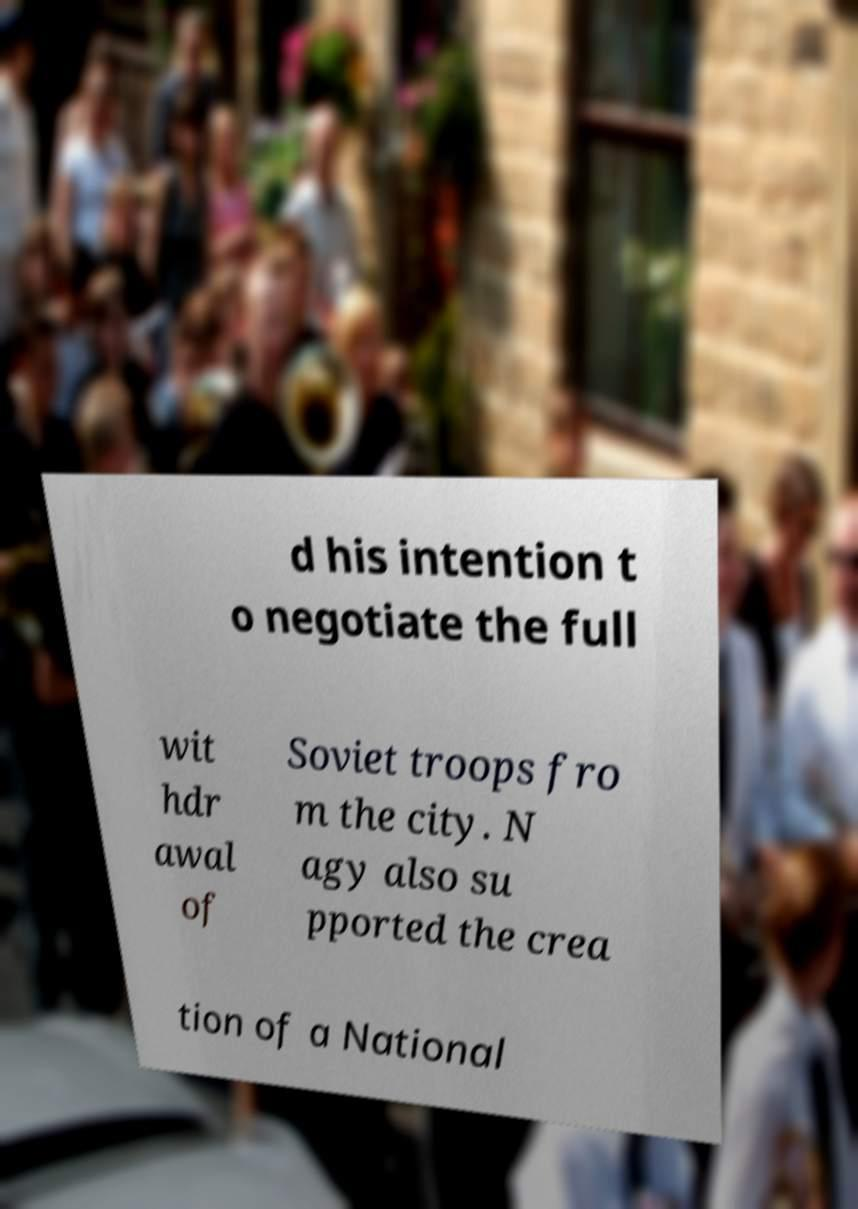Could you assist in decoding the text presented in this image and type it out clearly? d his intention t o negotiate the full wit hdr awal of Soviet troops fro m the city. N agy also su pported the crea tion of a National 